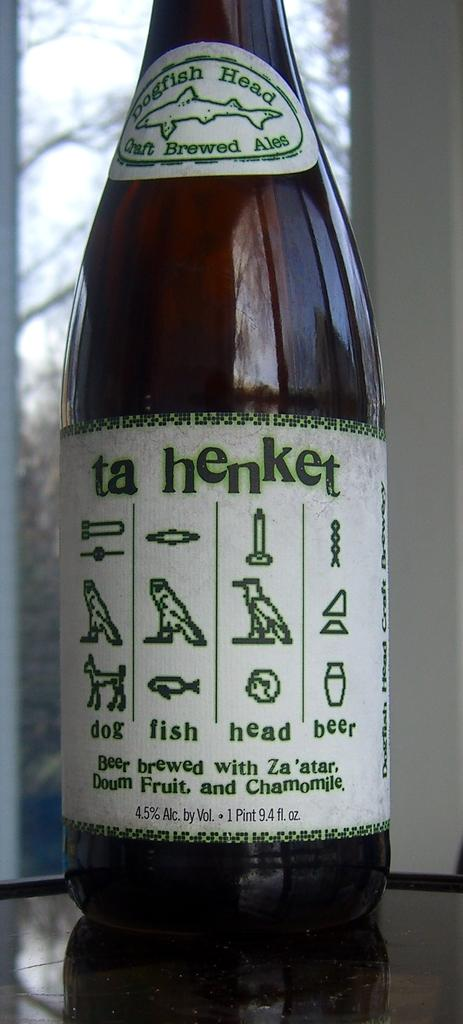<image>
Offer a succinct explanation of the picture presented. A bottle of Ta Henket beer has 4.5 percent alcohol by volume. 